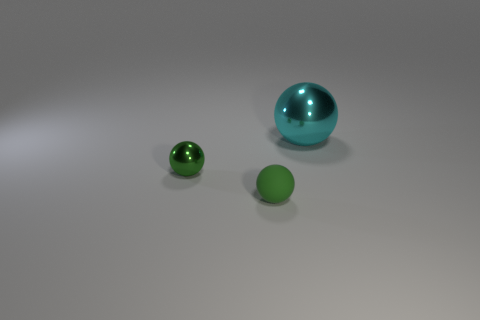Are there any rubber spheres that are in front of the green sphere that is to the right of the metallic thing that is in front of the large shiny ball?
Offer a very short reply. No. What number of large things are either green shiny things or purple cubes?
Offer a very short reply. 0. The metallic object that is the same size as the rubber sphere is what color?
Your answer should be compact. Green. There is a cyan shiny ball; what number of shiny balls are to the left of it?
Offer a terse response. 1. Are there any spheres made of the same material as the cyan object?
Keep it short and to the point. Yes. What shape is the shiny object that is the same color as the rubber thing?
Ensure brevity in your answer.  Sphere. What color is the shiny object that is left of the large metal thing?
Keep it short and to the point. Green. Are there an equal number of rubber things that are on the right side of the green matte sphere and tiny spheres behind the cyan shiny sphere?
Your response must be concise. Yes. What material is the tiny green ball that is in front of the metal sphere that is on the left side of the small green matte object?
Your response must be concise. Rubber. How many objects are cyan shiny spheres or things that are behind the tiny matte sphere?
Give a very brief answer. 2. 